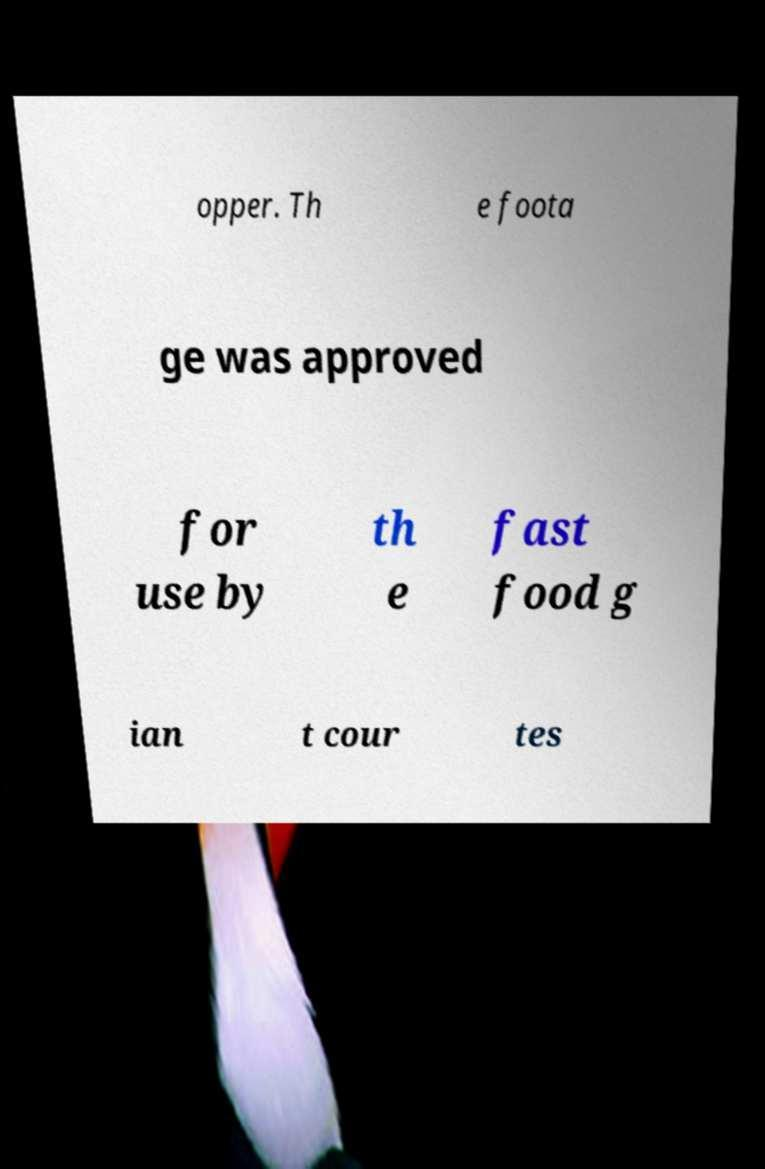For documentation purposes, I need the text within this image transcribed. Could you provide that? opper. Th e foota ge was approved for use by th e fast food g ian t cour tes 